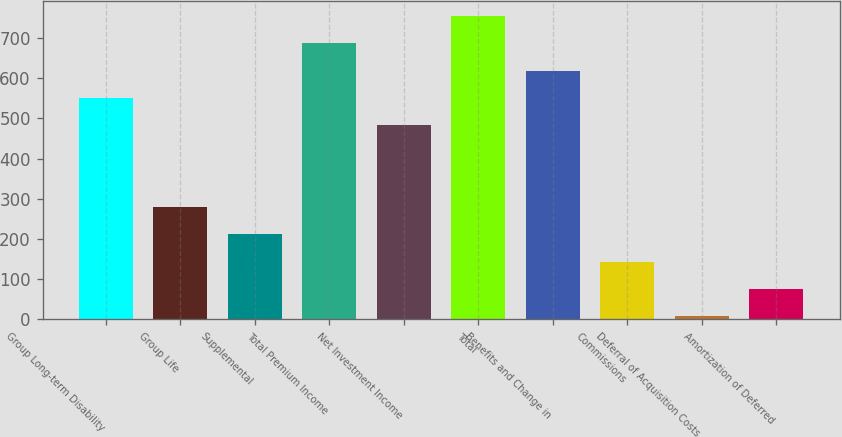Convert chart. <chart><loc_0><loc_0><loc_500><loc_500><bar_chart><fcel>Group Long-term Disability<fcel>Group Life<fcel>Supplemental<fcel>Total Premium Income<fcel>Net Investment Income<fcel>Total<fcel>Benefits and Change in<fcel>Commissions<fcel>Deferral of Acquisition Costs<fcel>Amortization of Deferred<nl><fcel>550.74<fcel>279.42<fcel>211.59<fcel>686.4<fcel>482.91<fcel>754.23<fcel>618.57<fcel>143.76<fcel>8.1<fcel>75.93<nl></chart> 